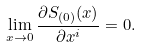<formula> <loc_0><loc_0><loc_500><loc_500>\lim _ { x \rightarrow 0 } { \frac { \partial S _ { ( 0 ) } ( x ) } { \partial x ^ { i } } } = 0 .</formula> 